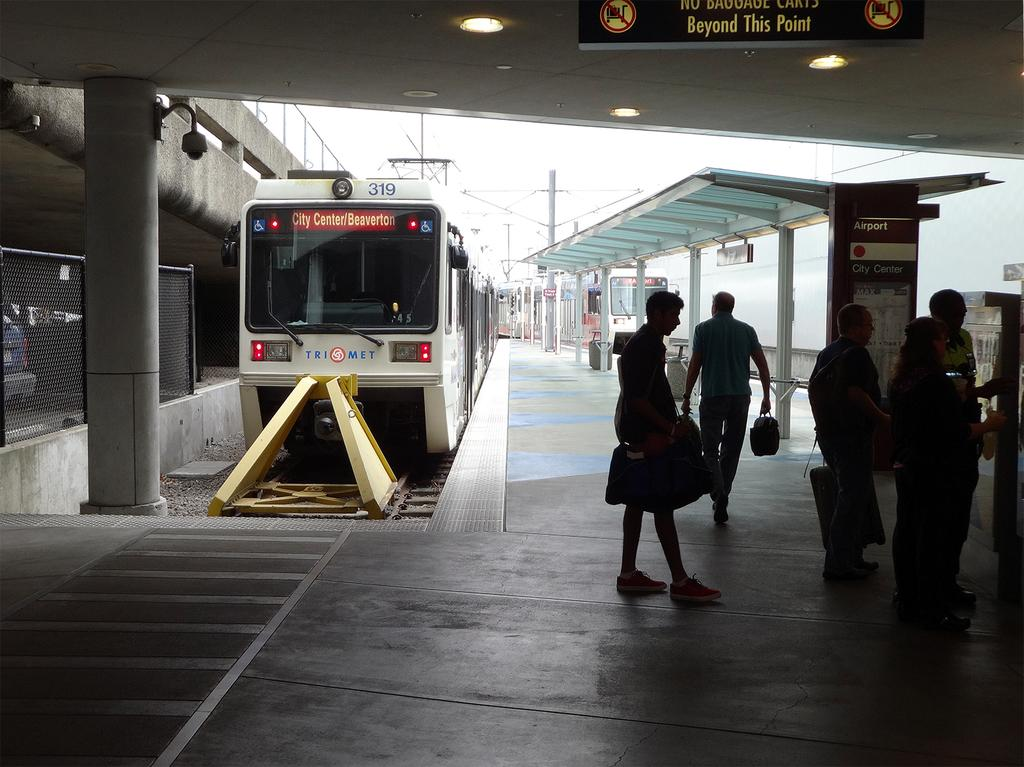<image>
Share a concise interpretation of the image provided. A bus going to the city center and also Beaverton 